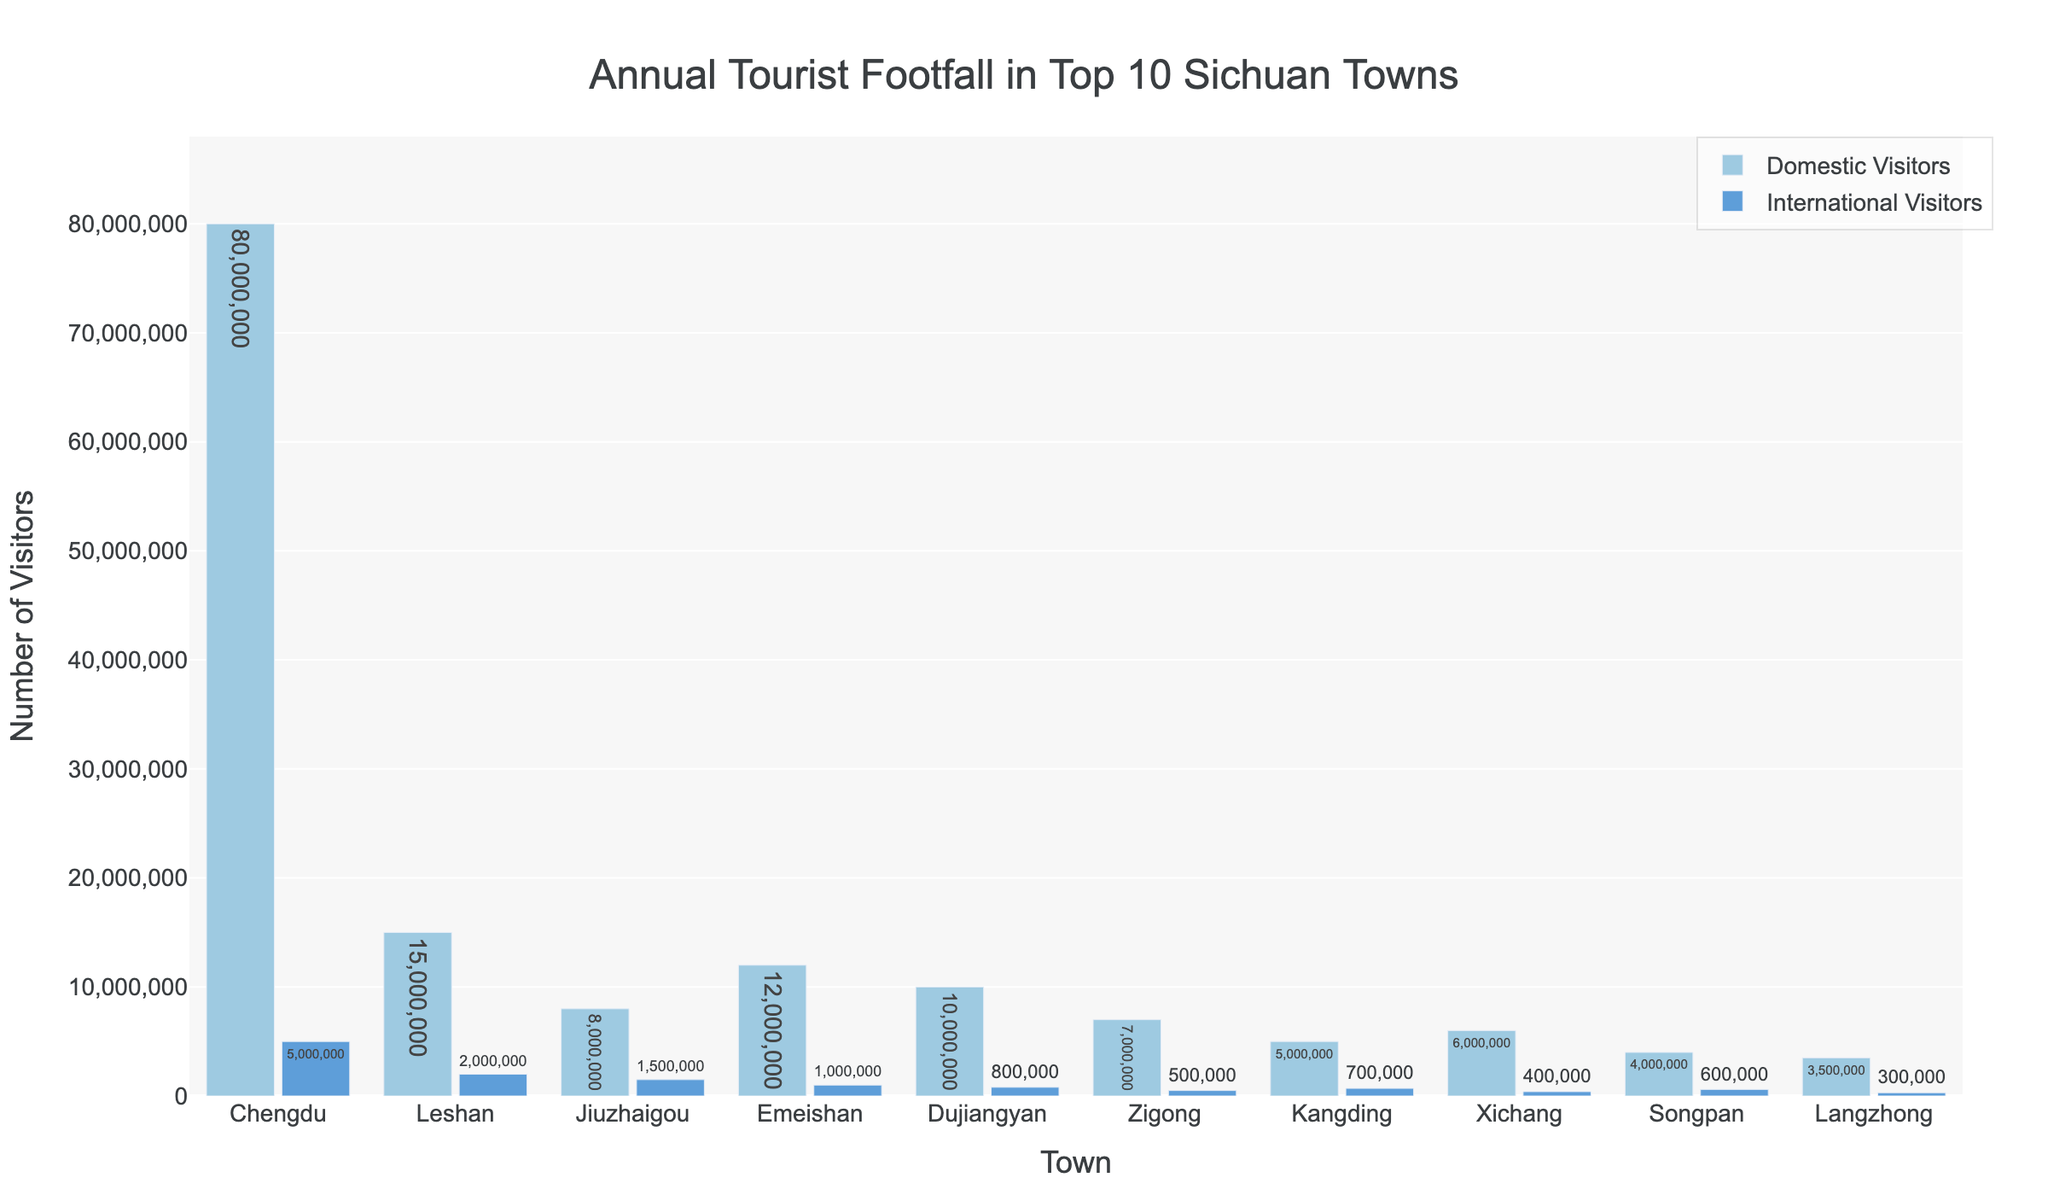Which town has the highest number of domestic visitors? According to the figure, Chengdu has the highest number of domestic visitors as shown by the tallest bar in the domestic visitors category.
Answer: Chengdu Which town has the lowest number of international visitors? The shortest bar in the international visitors category represents Langzhong, indicating it has the lowest number of international visitors.
Answer: Langzhong What is the difference in the number of domestic visitors between Chengdu and Leshan? Chengdu has 80,000,000 domestic visitors and Leshan has 15,000,000 domestic visitors. The difference is 80,000,000 - 15,000,000.
Answer: 65,000,000 Which towns have a higher number of international visitors than domestic visitors? Comparing the bar heights, there are no towns where the international visitors bar is higher than the domestic visitors bar.
Answer: None What is the total number of visitors (both domestic and international) for Zigong? Zigong has 7,000,000 domestic visitors and 500,000 international visitors. Their total is 7,000,000 + 500,000.
Answer: 7,500,000 Which town hosts more international visitors than Kangding and less than Xichang? Comparing the international visitors bars, Songpan has more than Kangding (700,000) and less than Xichang (400,000), which means it matches the criteria.
Answer: Songpan How many more domestic visitors does Dujiangyan have compared to Songpan? Dujiangyan has 10,000,000 domestic visitors and Songpan has 4,000,000. The difference is 10,000,000 - 4,000,000.
Answer: 6,000,000 What is the combined total of international visitors for Emeishan and Jiuzhaigou? Emeishan has 1,000,000 international visitors, and Jiuzhaigou has 1,500,000. The combined total is 1,000,000 + 1,500,000.
Answer: 2,500,000 Which town has fewer than 500,000 international visitors and more than 3,000,000 domestic visitors? Zigong has 500,000 international visitors and 7,000,000 domestic visitors, but only Xichang fits having fewer than 500,000 international visitors (400,000) and more than 3,000,000 domestic visitors (6,000,000).
Answer: Xichang 